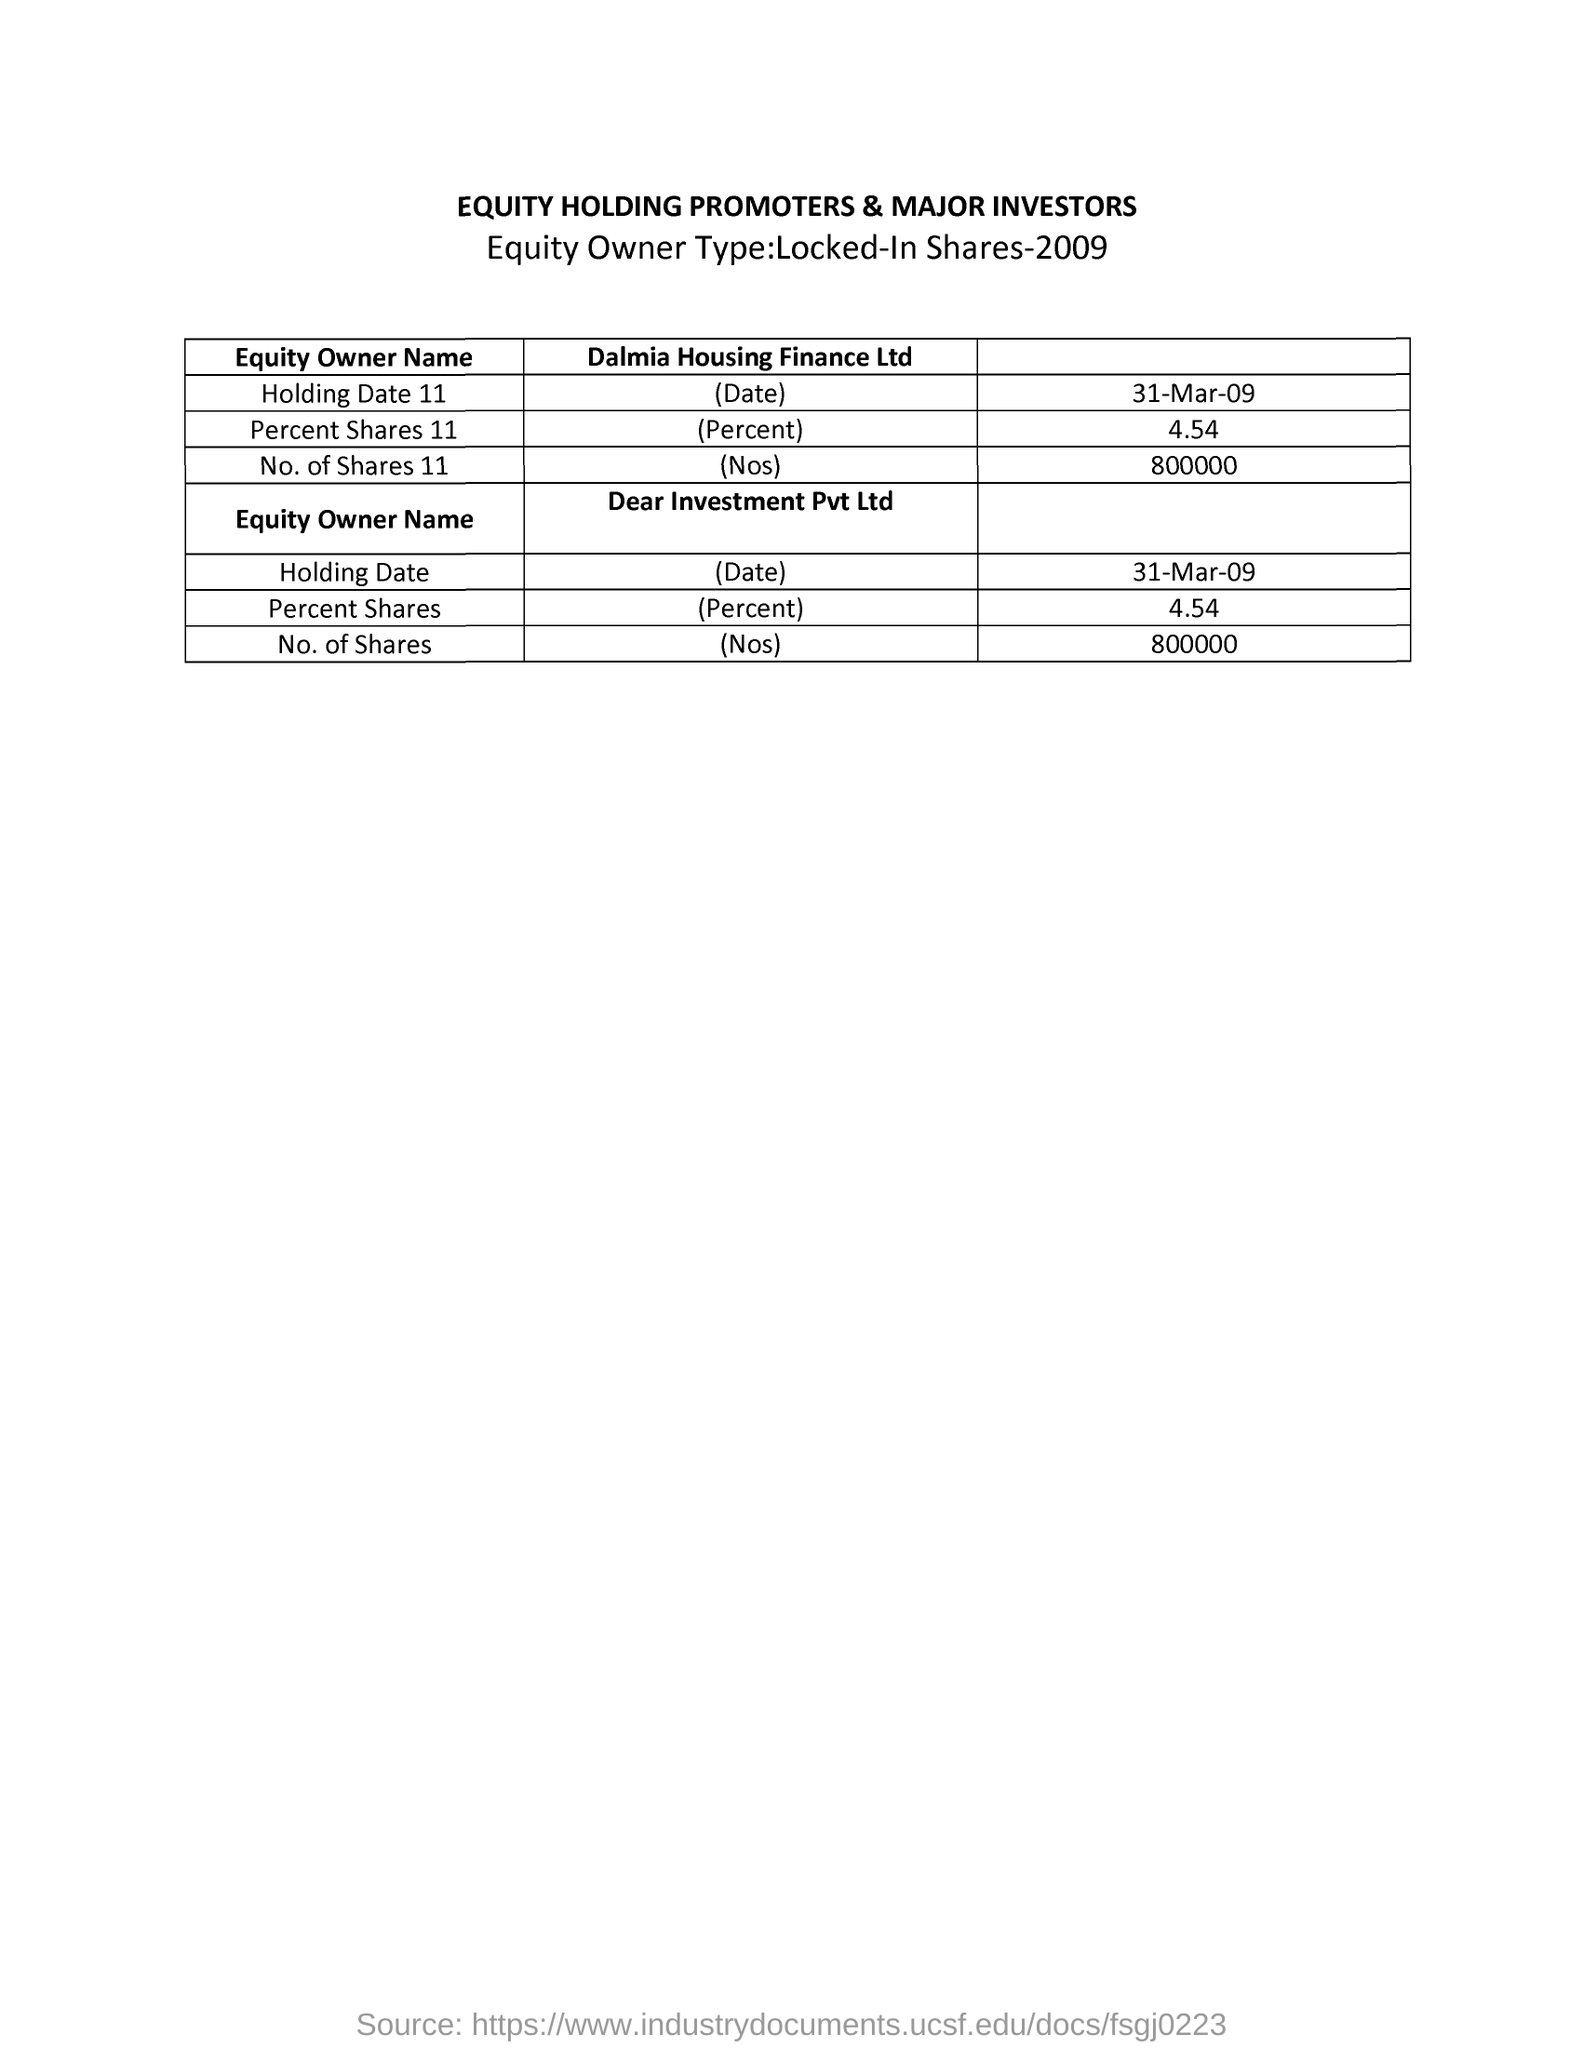Which is the Equity Owner Type?
Ensure brevity in your answer.  Locked-In Shares-2009. What is the title of the document?
Keep it short and to the point. EQUITY HOLDING PROMOTERS & MAJOR INVESTORS. Who is the second 'Equity Owner' ?
Your answer should be very brief. Dear Investment Pvt Ltd. What is the 'Holding Date' of 'Dear Investment Pvt Ltd' ?
Ensure brevity in your answer.  31-Mar-09. What is the 'Percent Shares 11' of 'Dalmia Housing Finance Ltd' ?
Your answer should be very brief. 4.54. How many no. of Shares for second Equity Owner?
Provide a short and direct response. 800000. 